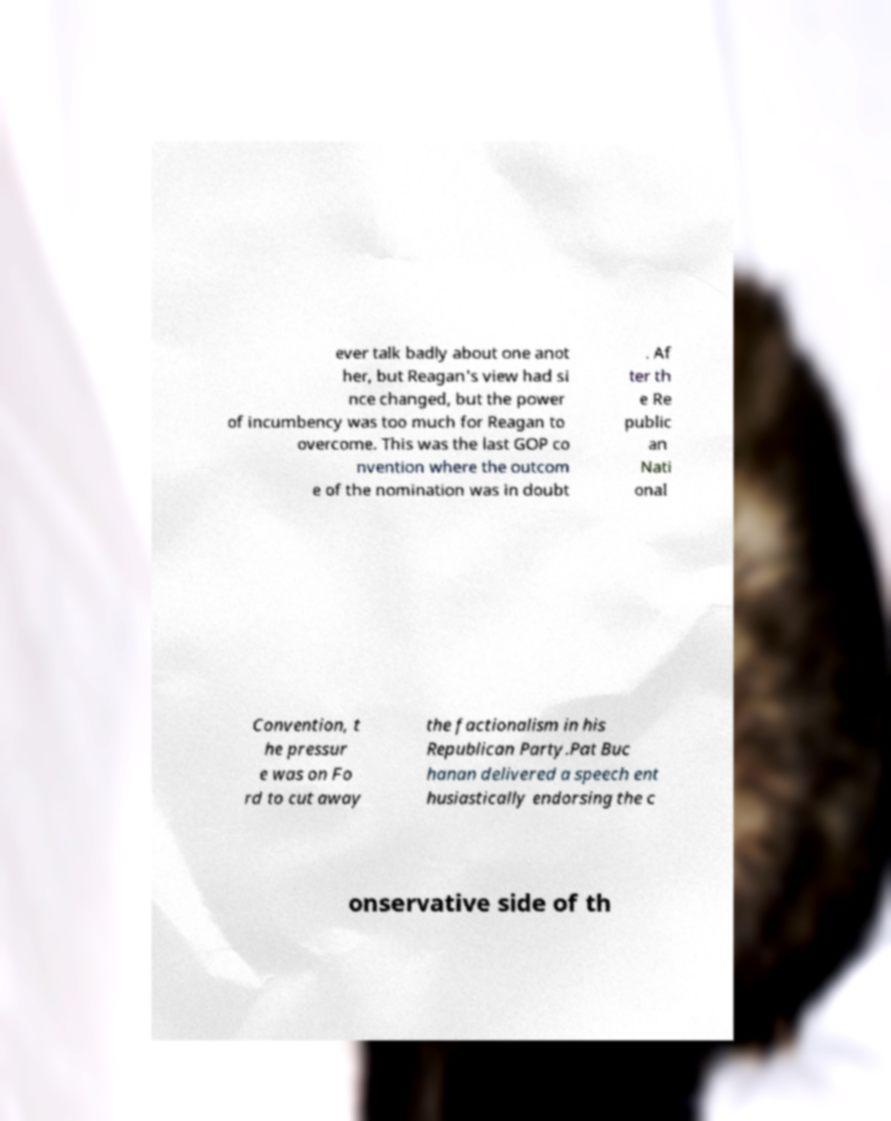Could you extract and type out the text from this image? ever talk badly about one anot her, but Reagan's view had si nce changed, but the power of incumbency was too much for Reagan to overcome. This was the last GOP co nvention where the outcom e of the nomination was in doubt . Af ter th e Re public an Nati onal Convention, t he pressur e was on Fo rd to cut away the factionalism in his Republican Party.Pat Buc hanan delivered a speech ent husiastically endorsing the c onservative side of th 